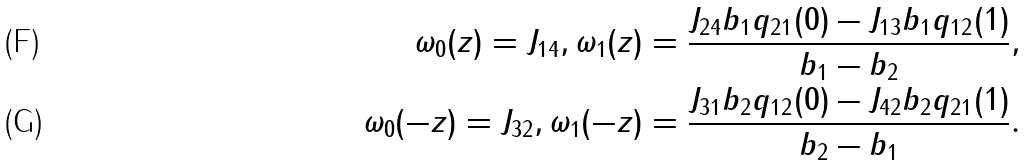Convert formula to latex. <formula><loc_0><loc_0><loc_500><loc_500>\omega _ { 0 } ( z ) = J _ { 1 4 } , \omega _ { 1 } ( z ) = \frac { J _ { 2 4 } b _ { 1 } q _ { 2 1 } ( 0 ) - J _ { 1 3 } b _ { 1 } q _ { 1 2 } ( 1 ) } { b _ { 1 } - b _ { 2 } } , \\ \omega _ { 0 } ( - z ) = J _ { 3 2 } , \omega _ { 1 } ( - z ) = \frac { J _ { 3 1 } b _ { 2 } q _ { 1 2 } ( 0 ) - J _ { 4 2 } b _ { 2 } q _ { 2 1 } ( 1 ) } { b _ { 2 } - b _ { 1 } } .</formula> 